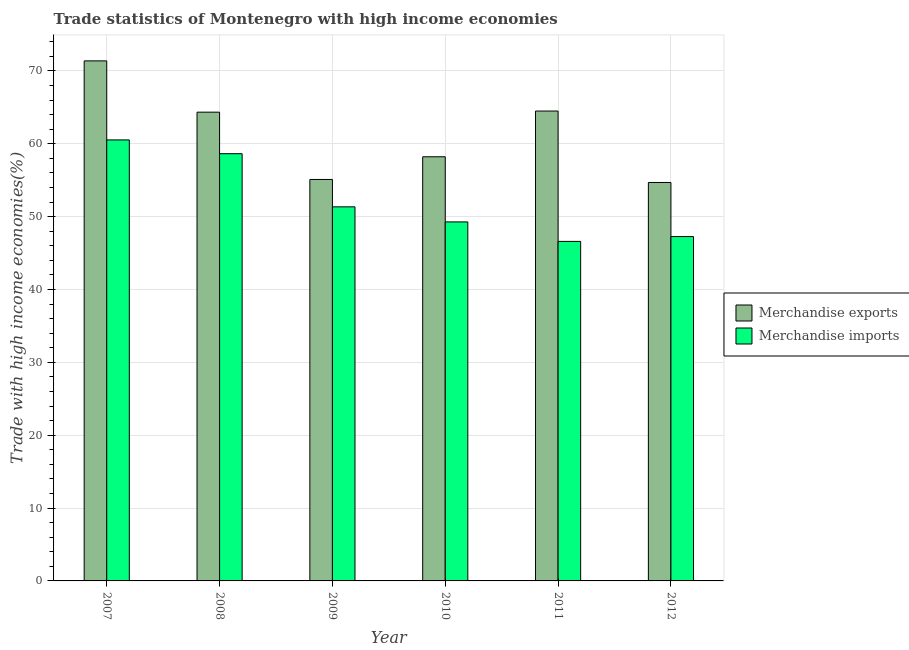How many groups of bars are there?
Keep it short and to the point. 6. Are the number of bars per tick equal to the number of legend labels?
Your answer should be compact. Yes. How many bars are there on the 1st tick from the left?
Provide a short and direct response. 2. How many bars are there on the 1st tick from the right?
Give a very brief answer. 2. What is the label of the 6th group of bars from the left?
Provide a short and direct response. 2012. In how many cases, is the number of bars for a given year not equal to the number of legend labels?
Provide a succinct answer. 0. What is the merchandise imports in 2012?
Provide a short and direct response. 47.27. Across all years, what is the maximum merchandise exports?
Offer a very short reply. 71.38. Across all years, what is the minimum merchandise exports?
Your answer should be compact. 54.69. In which year was the merchandise imports maximum?
Ensure brevity in your answer.  2007. What is the total merchandise exports in the graph?
Keep it short and to the point. 368.23. What is the difference between the merchandise imports in 2007 and that in 2010?
Make the answer very short. 11.26. What is the difference between the merchandise exports in 2009 and the merchandise imports in 2007?
Your answer should be compact. -16.28. What is the average merchandise imports per year?
Keep it short and to the point. 52.28. In how many years, is the merchandise exports greater than 8 %?
Your answer should be very brief. 6. What is the ratio of the merchandise imports in 2009 to that in 2012?
Offer a very short reply. 1.09. Is the merchandise exports in 2009 less than that in 2011?
Provide a short and direct response. Yes. Is the difference between the merchandise imports in 2007 and 2009 greater than the difference between the merchandise exports in 2007 and 2009?
Your response must be concise. No. What is the difference between the highest and the second highest merchandise imports?
Make the answer very short. 1.89. What is the difference between the highest and the lowest merchandise exports?
Ensure brevity in your answer.  16.69. In how many years, is the merchandise imports greater than the average merchandise imports taken over all years?
Offer a terse response. 2. Is the sum of the merchandise imports in 2008 and 2012 greater than the maximum merchandise exports across all years?
Your answer should be compact. Yes. Are all the bars in the graph horizontal?
Your answer should be very brief. No. What is the difference between two consecutive major ticks on the Y-axis?
Your response must be concise. 10. Are the values on the major ticks of Y-axis written in scientific E-notation?
Offer a terse response. No. Does the graph contain any zero values?
Offer a terse response. No. Does the graph contain grids?
Provide a short and direct response. Yes. Where does the legend appear in the graph?
Provide a short and direct response. Center right. How many legend labels are there?
Your answer should be very brief. 2. What is the title of the graph?
Keep it short and to the point. Trade statistics of Montenegro with high income economies. What is the label or title of the Y-axis?
Your response must be concise. Trade with high income economies(%). What is the Trade with high income economies(%) in Merchandise exports in 2007?
Offer a very short reply. 71.38. What is the Trade with high income economies(%) in Merchandise imports in 2007?
Your answer should be very brief. 60.53. What is the Trade with high income economies(%) of Merchandise exports in 2008?
Your answer should be very brief. 64.34. What is the Trade with high income economies(%) in Merchandise imports in 2008?
Your response must be concise. 58.64. What is the Trade with high income economies(%) in Merchandise exports in 2009?
Give a very brief answer. 55.1. What is the Trade with high income economies(%) in Merchandise imports in 2009?
Ensure brevity in your answer.  51.35. What is the Trade with high income economies(%) of Merchandise exports in 2010?
Keep it short and to the point. 58.22. What is the Trade with high income economies(%) of Merchandise imports in 2010?
Provide a succinct answer. 49.28. What is the Trade with high income economies(%) of Merchandise exports in 2011?
Your answer should be compact. 64.49. What is the Trade with high income economies(%) in Merchandise imports in 2011?
Offer a very short reply. 46.6. What is the Trade with high income economies(%) of Merchandise exports in 2012?
Offer a terse response. 54.69. What is the Trade with high income economies(%) in Merchandise imports in 2012?
Your answer should be compact. 47.27. Across all years, what is the maximum Trade with high income economies(%) of Merchandise exports?
Provide a short and direct response. 71.38. Across all years, what is the maximum Trade with high income economies(%) in Merchandise imports?
Your response must be concise. 60.53. Across all years, what is the minimum Trade with high income economies(%) in Merchandise exports?
Offer a very short reply. 54.69. Across all years, what is the minimum Trade with high income economies(%) of Merchandise imports?
Offer a terse response. 46.6. What is the total Trade with high income economies(%) in Merchandise exports in the graph?
Provide a succinct answer. 368.23. What is the total Trade with high income economies(%) in Merchandise imports in the graph?
Your answer should be very brief. 313.66. What is the difference between the Trade with high income economies(%) in Merchandise exports in 2007 and that in 2008?
Your answer should be compact. 7.04. What is the difference between the Trade with high income economies(%) in Merchandise imports in 2007 and that in 2008?
Provide a succinct answer. 1.89. What is the difference between the Trade with high income economies(%) in Merchandise exports in 2007 and that in 2009?
Ensure brevity in your answer.  16.28. What is the difference between the Trade with high income economies(%) in Merchandise imports in 2007 and that in 2009?
Keep it short and to the point. 9.18. What is the difference between the Trade with high income economies(%) in Merchandise exports in 2007 and that in 2010?
Provide a succinct answer. 13.16. What is the difference between the Trade with high income economies(%) of Merchandise imports in 2007 and that in 2010?
Give a very brief answer. 11.26. What is the difference between the Trade with high income economies(%) in Merchandise exports in 2007 and that in 2011?
Give a very brief answer. 6.89. What is the difference between the Trade with high income economies(%) of Merchandise imports in 2007 and that in 2011?
Ensure brevity in your answer.  13.93. What is the difference between the Trade with high income economies(%) in Merchandise exports in 2007 and that in 2012?
Offer a terse response. 16.69. What is the difference between the Trade with high income economies(%) in Merchandise imports in 2007 and that in 2012?
Give a very brief answer. 13.27. What is the difference between the Trade with high income economies(%) of Merchandise exports in 2008 and that in 2009?
Make the answer very short. 9.24. What is the difference between the Trade with high income economies(%) of Merchandise imports in 2008 and that in 2009?
Your answer should be compact. 7.29. What is the difference between the Trade with high income economies(%) in Merchandise exports in 2008 and that in 2010?
Your answer should be very brief. 6.12. What is the difference between the Trade with high income economies(%) of Merchandise imports in 2008 and that in 2010?
Keep it short and to the point. 9.36. What is the difference between the Trade with high income economies(%) in Merchandise exports in 2008 and that in 2011?
Provide a short and direct response. -0.15. What is the difference between the Trade with high income economies(%) of Merchandise imports in 2008 and that in 2011?
Provide a short and direct response. 12.04. What is the difference between the Trade with high income economies(%) in Merchandise exports in 2008 and that in 2012?
Your response must be concise. 9.65. What is the difference between the Trade with high income economies(%) of Merchandise imports in 2008 and that in 2012?
Your response must be concise. 11.37. What is the difference between the Trade with high income economies(%) of Merchandise exports in 2009 and that in 2010?
Make the answer very short. -3.12. What is the difference between the Trade with high income economies(%) of Merchandise imports in 2009 and that in 2010?
Provide a succinct answer. 2.07. What is the difference between the Trade with high income economies(%) of Merchandise exports in 2009 and that in 2011?
Your answer should be very brief. -9.39. What is the difference between the Trade with high income economies(%) in Merchandise imports in 2009 and that in 2011?
Offer a terse response. 4.75. What is the difference between the Trade with high income economies(%) of Merchandise exports in 2009 and that in 2012?
Provide a short and direct response. 0.41. What is the difference between the Trade with high income economies(%) of Merchandise imports in 2009 and that in 2012?
Provide a short and direct response. 4.08. What is the difference between the Trade with high income economies(%) in Merchandise exports in 2010 and that in 2011?
Give a very brief answer. -6.28. What is the difference between the Trade with high income economies(%) in Merchandise imports in 2010 and that in 2011?
Provide a short and direct response. 2.67. What is the difference between the Trade with high income economies(%) in Merchandise exports in 2010 and that in 2012?
Provide a short and direct response. 3.53. What is the difference between the Trade with high income economies(%) in Merchandise imports in 2010 and that in 2012?
Offer a very short reply. 2.01. What is the difference between the Trade with high income economies(%) of Merchandise exports in 2011 and that in 2012?
Provide a succinct answer. 9.81. What is the difference between the Trade with high income economies(%) of Merchandise imports in 2011 and that in 2012?
Keep it short and to the point. -0.66. What is the difference between the Trade with high income economies(%) in Merchandise exports in 2007 and the Trade with high income economies(%) in Merchandise imports in 2008?
Offer a very short reply. 12.74. What is the difference between the Trade with high income economies(%) in Merchandise exports in 2007 and the Trade with high income economies(%) in Merchandise imports in 2009?
Keep it short and to the point. 20.03. What is the difference between the Trade with high income economies(%) of Merchandise exports in 2007 and the Trade with high income economies(%) of Merchandise imports in 2010?
Offer a very short reply. 22.1. What is the difference between the Trade with high income economies(%) in Merchandise exports in 2007 and the Trade with high income economies(%) in Merchandise imports in 2011?
Offer a terse response. 24.78. What is the difference between the Trade with high income economies(%) in Merchandise exports in 2007 and the Trade with high income economies(%) in Merchandise imports in 2012?
Offer a terse response. 24.12. What is the difference between the Trade with high income economies(%) of Merchandise exports in 2008 and the Trade with high income economies(%) of Merchandise imports in 2009?
Your answer should be very brief. 12.99. What is the difference between the Trade with high income economies(%) in Merchandise exports in 2008 and the Trade with high income economies(%) in Merchandise imports in 2010?
Make the answer very short. 15.07. What is the difference between the Trade with high income economies(%) in Merchandise exports in 2008 and the Trade with high income economies(%) in Merchandise imports in 2011?
Provide a short and direct response. 17.74. What is the difference between the Trade with high income economies(%) of Merchandise exports in 2008 and the Trade with high income economies(%) of Merchandise imports in 2012?
Make the answer very short. 17.08. What is the difference between the Trade with high income economies(%) of Merchandise exports in 2009 and the Trade with high income economies(%) of Merchandise imports in 2010?
Your answer should be compact. 5.83. What is the difference between the Trade with high income economies(%) of Merchandise exports in 2009 and the Trade with high income economies(%) of Merchandise imports in 2011?
Make the answer very short. 8.5. What is the difference between the Trade with high income economies(%) in Merchandise exports in 2009 and the Trade with high income economies(%) in Merchandise imports in 2012?
Offer a very short reply. 7.84. What is the difference between the Trade with high income economies(%) in Merchandise exports in 2010 and the Trade with high income economies(%) in Merchandise imports in 2011?
Offer a very short reply. 11.62. What is the difference between the Trade with high income economies(%) in Merchandise exports in 2010 and the Trade with high income economies(%) in Merchandise imports in 2012?
Keep it short and to the point. 10.95. What is the difference between the Trade with high income economies(%) in Merchandise exports in 2011 and the Trade with high income economies(%) in Merchandise imports in 2012?
Offer a terse response. 17.23. What is the average Trade with high income economies(%) in Merchandise exports per year?
Provide a short and direct response. 61.37. What is the average Trade with high income economies(%) of Merchandise imports per year?
Make the answer very short. 52.28. In the year 2007, what is the difference between the Trade with high income economies(%) in Merchandise exports and Trade with high income economies(%) in Merchandise imports?
Give a very brief answer. 10.85. In the year 2008, what is the difference between the Trade with high income economies(%) in Merchandise exports and Trade with high income economies(%) in Merchandise imports?
Offer a terse response. 5.7. In the year 2009, what is the difference between the Trade with high income economies(%) in Merchandise exports and Trade with high income economies(%) in Merchandise imports?
Ensure brevity in your answer.  3.76. In the year 2010, what is the difference between the Trade with high income economies(%) in Merchandise exports and Trade with high income economies(%) in Merchandise imports?
Keep it short and to the point. 8.94. In the year 2011, what is the difference between the Trade with high income economies(%) of Merchandise exports and Trade with high income economies(%) of Merchandise imports?
Offer a terse response. 17.89. In the year 2012, what is the difference between the Trade with high income economies(%) in Merchandise exports and Trade with high income economies(%) in Merchandise imports?
Keep it short and to the point. 7.42. What is the ratio of the Trade with high income economies(%) of Merchandise exports in 2007 to that in 2008?
Keep it short and to the point. 1.11. What is the ratio of the Trade with high income economies(%) in Merchandise imports in 2007 to that in 2008?
Offer a very short reply. 1.03. What is the ratio of the Trade with high income economies(%) in Merchandise exports in 2007 to that in 2009?
Your response must be concise. 1.3. What is the ratio of the Trade with high income economies(%) of Merchandise imports in 2007 to that in 2009?
Your answer should be compact. 1.18. What is the ratio of the Trade with high income economies(%) in Merchandise exports in 2007 to that in 2010?
Your answer should be compact. 1.23. What is the ratio of the Trade with high income economies(%) of Merchandise imports in 2007 to that in 2010?
Provide a short and direct response. 1.23. What is the ratio of the Trade with high income economies(%) in Merchandise exports in 2007 to that in 2011?
Give a very brief answer. 1.11. What is the ratio of the Trade with high income economies(%) in Merchandise imports in 2007 to that in 2011?
Keep it short and to the point. 1.3. What is the ratio of the Trade with high income economies(%) of Merchandise exports in 2007 to that in 2012?
Offer a very short reply. 1.31. What is the ratio of the Trade with high income economies(%) of Merchandise imports in 2007 to that in 2012?
Give a very brief answer. 1.28. What is the ratio of the Trade with high income economies(%) in Merchandise exports in 2008 to that in 2009?
Offer a very short reply. 1.17. What is the ratio of the Trade with high income economies(%) of Merchandise imports in 2008 to that in 2009?
Your response must be concise. 1.14. What is the ratio of the Trade with high income economies(%) in Merchandise exports in 2008 to that in 2010?
Provide a succinct answer. 1.11. What is the ratio of the Trade with high income economies(%) of Merchandise imports in 2008 to that in 2010?
Give a very brief answer. 1.19. What is the ratio of the Trade with high income economies(%) in Merchandise imports in 2008 to that in 2011?
Make the answer very short. 1.26. What is the ratio of the Trade with high income economies(%) of Merchandise exports in 2008 to that in 2012?
Ensure brevity in your answer.  1.18. What is the ratio of the Trade with high income economies(%) of Merchandise imports in 2008 to that in 2012?
Provide a short and direct response. 1.24. What is the ratio of the Trade with high income economies(%) of Merchandise exports in 2009 to that in 2010?
Your answer should be compact. 0.95. What is the ratio of the Trade with high income economies(%) of Merchandise imports in 2009 to that in 2010?
Keep it short and to the point. 1.04. What is the ratio of the Trade with high income economies(%) in Merchandise exports in 2009 to that in 2011?
Offer a very short reply. 0.85. What is the ratio of the Trade with high income economies(%) in Merchandise imports in 2009 to that in 2011?
Keep it short and to the point. 1.1. What is the ratio of the Trade with high income economies(%) in Merchandise exports in 2009 to that in 2012?
Make the answer very short. 1.01. What is the ratio of the Trade with high income economies(%) of Merchandise imports in 2009 to that in 2012?
Provide a succinct answer. 1.09. What is the ratio of the Trade with high income economies(%) of Merchandise exports in 2010 to that in 2011?
Keep it short and to the point. 0.9. What is the ratio of the Trade with high income economies(%) of Merchandise imports in 2010 to that in 2011?
Make the answer very short. 1.06. What is the ratio of the Trade with high income economies(%) in Merchandise exports in 2010 to that in 2012?
Your answer should be very brief. 1.06. What is the ratio of the Trade with high income economies(%) in Merchandise imports in 2010 to that in 2012?
Your answer should be compact. 1.04. What is the ratio of the Trade with high income economies(%) of Merchandise exports in 2011 to that in 2012?
Your response must be concise. 1.18. What is the ratio of the Trade with high income economies(%) of Merchandise imports in 2011 to that in 2012?
Ensure brevity in your answer.  0.99. What is the difference between the highest and the second highest Trade with high income economies(%) in Merchandise exports?
Offer a terse response. 6.89. What is the difference between the highest and the second highest Trade with high income economies(%) in Merchandise imports?
Give a very brief answer. 1.89. What is the difference between the highest and the lowest Trade with high income economies(%) in Merchandise exports?
Your answer should be compact. 16.69. What is the difference between the highest and the lowest Trade with high income economies(%) of Merchandise imports?
Keep it short and to the point. 13.93. 